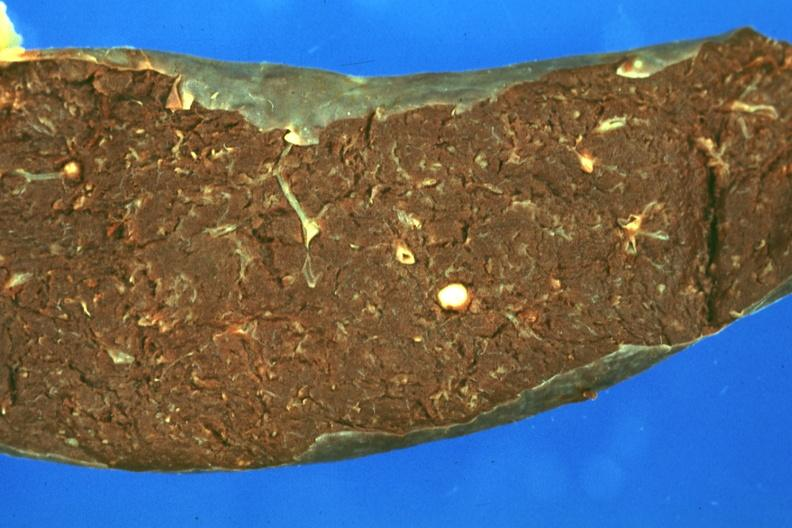what is present?
Answer the question using a single word or phrase. Spleen 